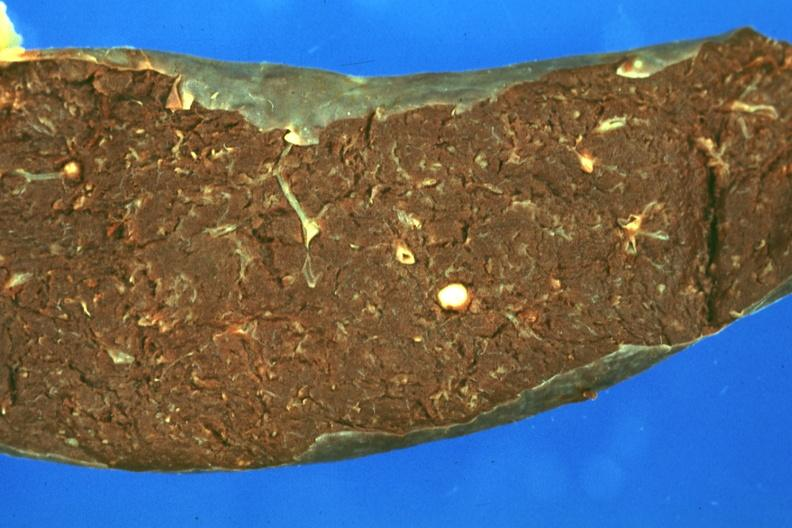what is present?
Answer the question using a single word or phrase. Spleen 